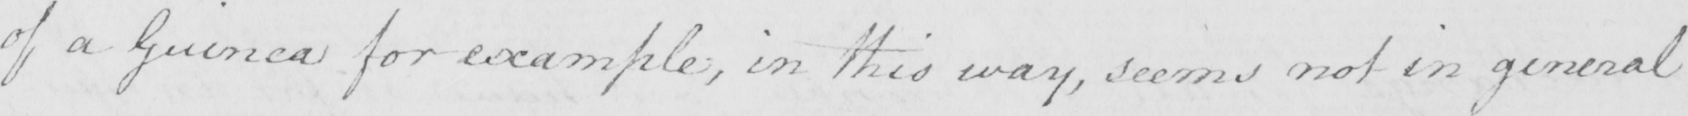Can you read and transcribe this handwriting? of a Guinea for example , in this way , seems not in general 